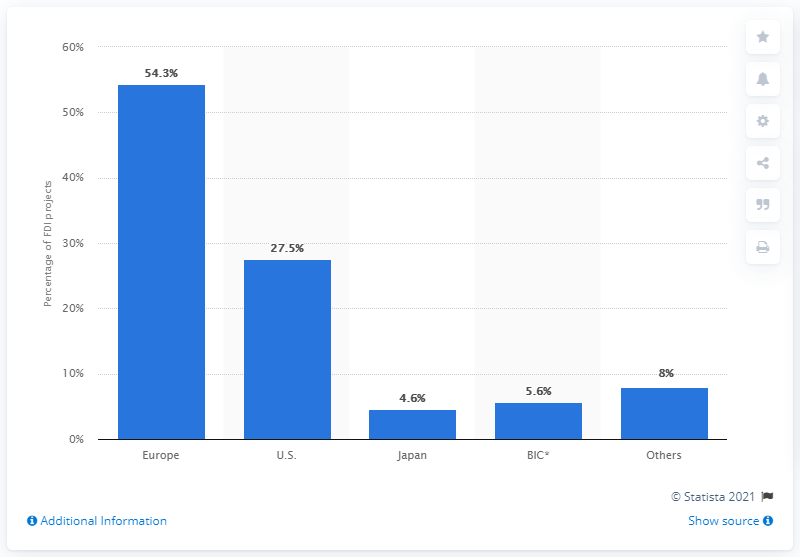Highlight a few significant elements in this photo. The sum of the least three values is 18.2. According to data from 2012, approximately 5.6% of Foreign Direct Investment (FDI) originated in the Brussels-Capital Region (BIC). The country with the highest Foreign Direct Investment (FDI) is Europe. 